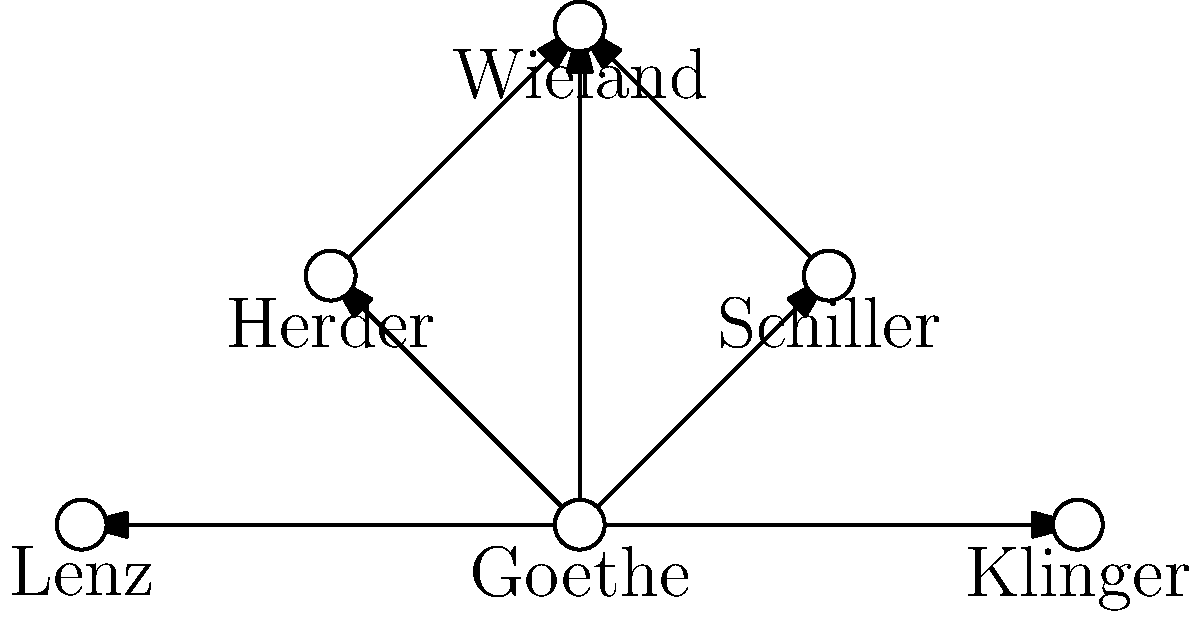Based on the network diagram of German literary figures, which poet appears to have the most direct connections to other writers in the Weimar circle? To determine which poet has the most direct connections in the Weimar circle, we need to analyze the network diagram step-by-step:

1. Identify all poets in the diagram:
   - Goethe
   - Schiller
   - Herder
   - Wieland
   - Lenz
   - Klinger

2. Count the connections for each poet:
   - Goethe: 5 connections (to Schiller, Herder, Wieland, Lenz, and Klinger)
   - Schiller: 2 connections (to Goethe and Wieland)
   - Herder: 2 connections (to Goethe and Wieland)
   - Wieland: 3 connections (to Goethe, Schiller, and Herder)
   - Lenz: 1 connection (to Goethe)
   - Klinger: 1 connection (to Goethe)

3. Identify the poet with the most connections:
   Goethe has the highest number of connections (5), significantly more than any other poet in the diagram.

4. Historical context:
   This network accurately represents Goethe's central role in the Weimar circle. As a leading figure of the Sturm und Drang movement and later Weimar Classicism, Goethe maintained close relationships with many prominent writers of his time.
Answer: Goethe 